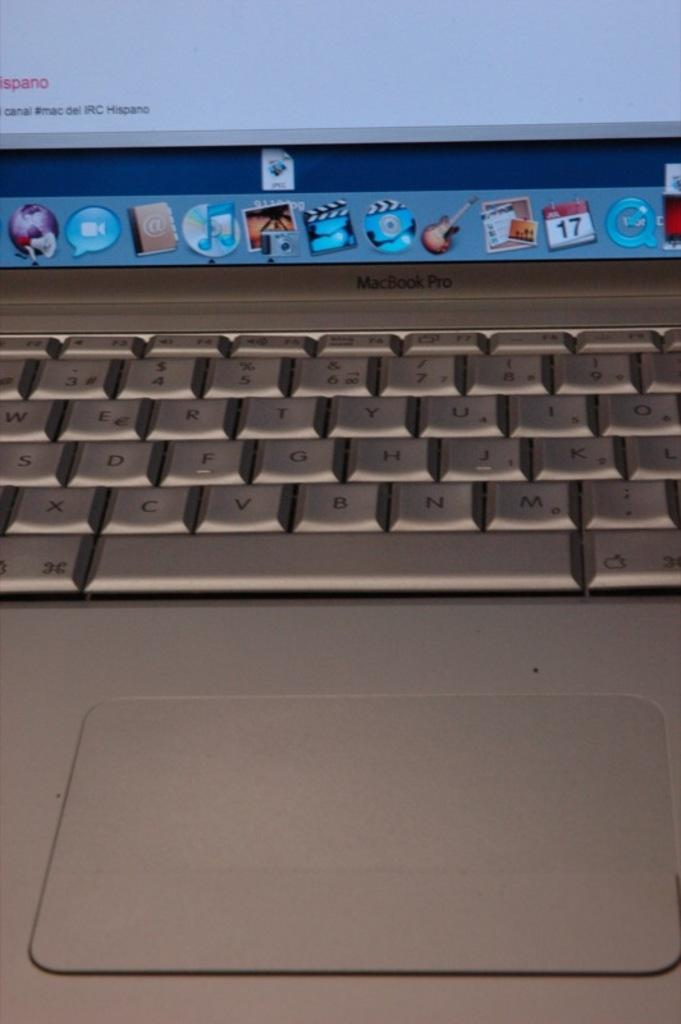<image>
Create a compact narrative representing the image presented. A MacBook Pro lap top computer keyboard and icon display 